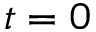Convert formula to latex. <formula><loc_0><loc_0><loc_500><loc_500>t = 0</formula> 